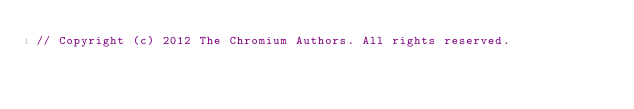Convert code to text. <code><loc_0><loc_0><loc_500><loc_500><_ObjectiveC_>// Copyright (c) 2012 The Chromium Authors. All rights reserved.</code> 